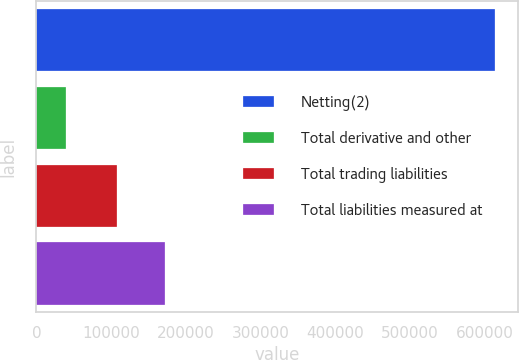Convert chart. <chart><loc_0><loc_0><loc_500><loc_500><bar_chart><fcel>Netting(2)<fcel>Total derivative and other<fcel>Total trading liabilities<fcel>Total liabilities measured at<nl><fcel>614094<fcel>40212<fcel>107381<fcel>171721<nl></chart> 